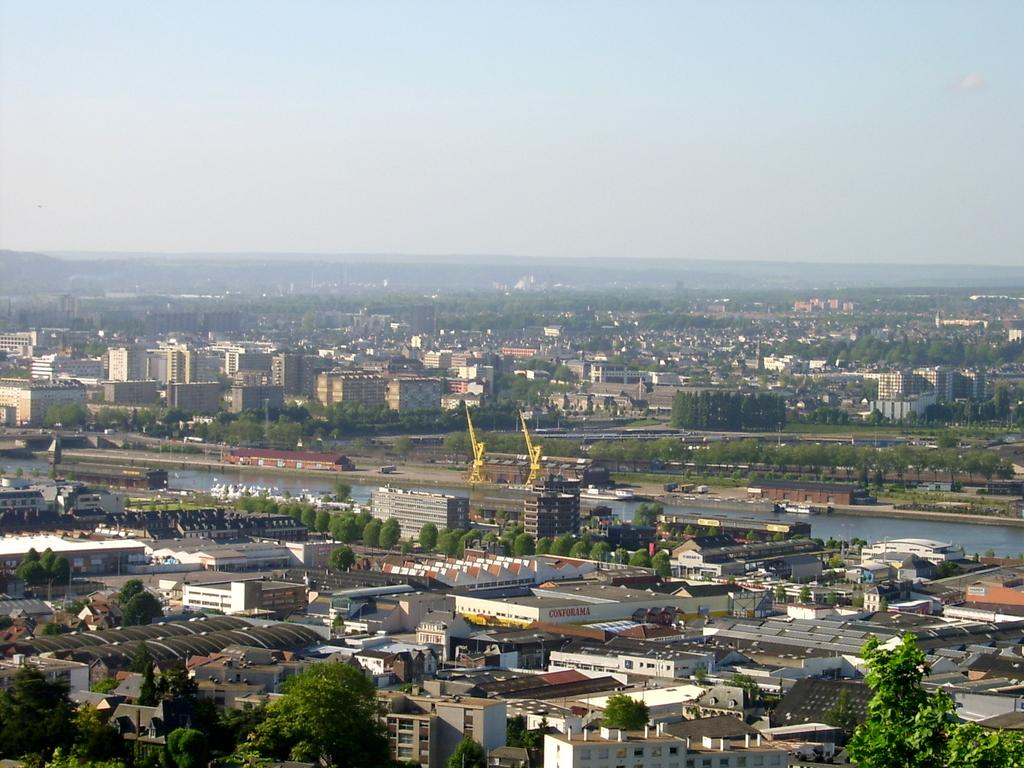What type of view is shown in the image? The image is an aerial view of a city. What natural elements can be seen in the image? There are trees and hills visible in the image. What man-made structures are present in the image? There are buildings, cranes, poles, and sign boards in the image. What natural feature can be seen in the image? There are watersheds in the image. What part of the sky is visible in the image? The sky is visible in the image. What type of powder is being used to create the hills in the image? There is no powder being used to create the hills in the image; they are natural landforms. 